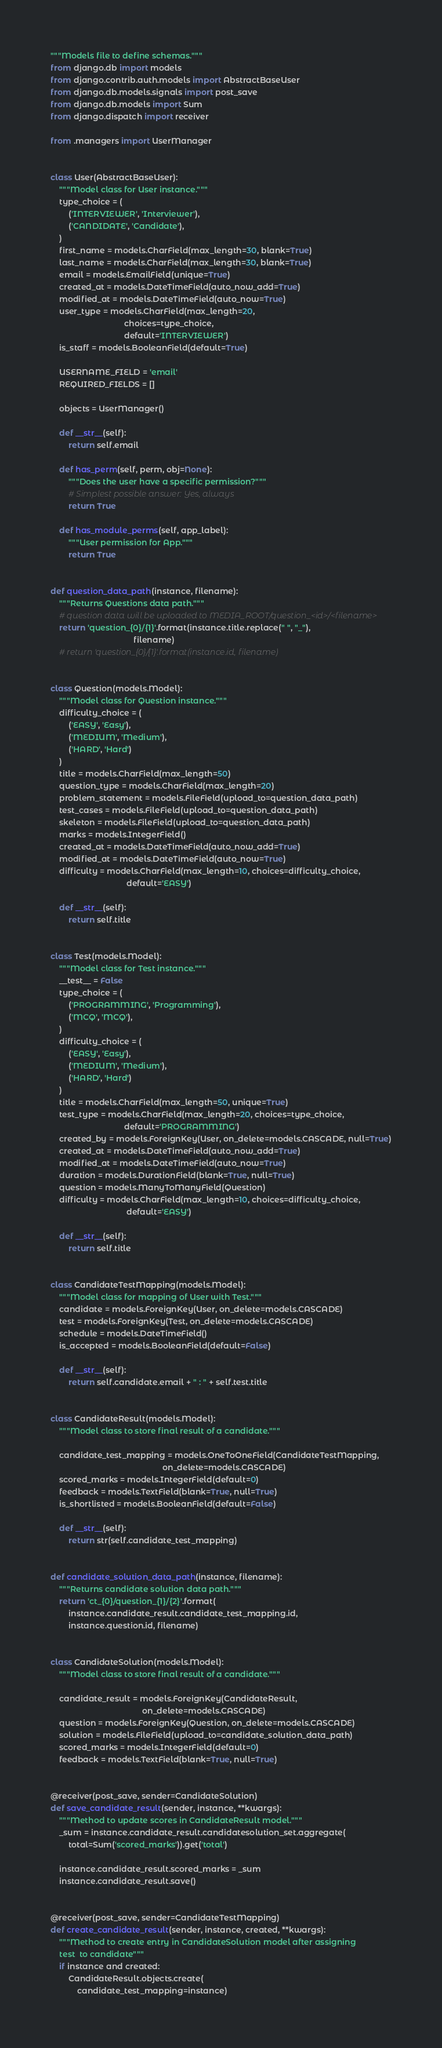Convert code to text. <code><loc_0><loc_0><loc_500><loc_500><_Python_>"""Models file to define schemas."""
from django.db import models
from django.contrib.auth.models import AbstractBaseUser
from django.db.models.signals import post_save
from django.db.models import Sum
from django.dispatch import receiver

from .managers import UserManager


class User(AbstractBaseUser):
    """Model class for User instance."""
    type_choice = (
        ('INTERVIEWER', 'Interviewer'),
        ('CANDIDATE', 'Candidate'),
    )
    first_name = models.CharField(max_length=30, blank=True)
    last_name = models.CharField(max_length=30, blank=True)
    email = models.EmailField(unique=True)
    created_at = models.DateTimeField(auto_now_add=True)
    modified_at = models.DateTimeField(auto_now=True)
    user_type = models.CharField(max_length=20,
                                 choices=type_choice,
                                 default='INTERVIEWER')
    is_staff = models.BooleanField(default=True)

    USERNAME_FIELD = 'email'
    REQUIRED_FIELDS = []

    objects = UserManager()

    def __str__(self):
        return self.email

    def has_perm(self, perm, obj=None):
        """Does the user have a specific permission?"""
        # Simplest possible answer: Yes, always
        return True

    def has_module_perms(self, app_label):
        """User permission for App."""
        return True


def question_data_path(instance, filename):
    """Returns Questions data path."""
    # question data will be uploaded to MEDIA_ROOT/question_<id>/<filename>
    return 'question_{0}/{1}'.format(instance.title.replace(" ", "_"),
                                     filename)
    # return 'question_{0}/{1}'.format(instance.id, filename)


class Question(models.Model):
    """Model class for Question instance."""
    difficulty_choice = (
        ('EASY', 'Easy'),
        ('MEDIUM', 'Medium'),
        ('HARD', 'Hard')
    )
    title = models.CharField(max_length=50)
    question_type = models.CharField(max_length=20)
    problem_statement = models.FileField(upload_to=question_data_path)
    test_cases = models.FileField(upload_to=question_data_path)
    skeleton = models.FileField(upload_to=question_data_path)
    marks = models.IntegerField()
    created_at = models.DateTimeField(auto_now_add=True)
    modified_at = models.DateTimeField(auto_now=True)
    difficulty = models.CharField(max_length=10, choices=difficulty_choice,
                                  default='EASY')

    def __str__(self):
        return self.title


class Test(models.Model):
    """Model class for Test instance."""
    __test__ = False
    type_choice = (
        ('PROGRAMMING', 'Programming'),
        ('MCQ', 'MCQ'),
    )
    difficulty_choice = (
        ('EASY', 'Easy'),
        ('MEDIUM', 'Medium'),
        ('HARD', 'Hard')
    )
    title = models.CharField(max_length=50, unique=True)
    test_type = models.CharField(max_length=20, choices=type_choice,
                                 default='PROGRAMMING')
    created_by = models.ForeignKey(User, on_delete=models.CASCADE, null=True)
    created_at = models.DateTimeField(auto_now_add=True)
    modified_at = models.DateTimeField(auto_now=True)
    duration = models.DurationField(blank=True, null=True)
    question = models.ManyToManyField(Question)
    difficulty = models.CharField(max_length=10, choices=difficulty_choice,
                                  default='EASY')

    def __str__(self):
        return self.title


class CandidateTestMapping(models.Model):
    """Model class for mapping of User with Test."""
    candidate = models.ForeignKey(User, on_delete=models.CASCADE)
    test = models.ForeignKey(Test, on_delete=models.CASCADE)
    schedule = models.DateTimeField()
    is_accepted = models.BooleanField(default=False)

    def __str__(self):
        return self.candidate.email + " : " + self.test.title


class CandidateResult(models.Model):
    """Model class to store final result of a candidate."""

    candidate_test_mapping = models.OneToOneField(CandidateTestMapping,
                                                  on_delete=models.CASCADE)
    scored_marks = models.IntegerField(default=0)
    feedback = models.TextField(blank=True, null=True)
    is_shortlisted = models.BooleanField(default=False)

    def __str__(self):
        return str(self.candidate_test_mapping)


def candidate_solution_data_path(instance, filename):
    """Returns candidate solution data path."""
    return 'ct_{0}/question_{1}/{2}'.format(
        instance.candidate_result.candidate_test_mapping.id,
        instance.question.id, filename)


class CandidateSolution(models.Model):
    """Model class to store final result of a candidate."""

    candidate_result = models.ForeignKey(CandidateResult,
                                         on_delete=models.CASCADE)
    question = models.ForeignKey(Question, on_delete=models.CASCADE)
    solution = models.FileField(upload_to=candidate_solution_data_path)
    scored_marks = models.IntegerField(default=0)
    feedback = models.TextField(blank=True, null=True)


@receiver(post_save, sender=CandidateSolution)
def save_candidate_result(sender, instance, **kwargs):
    """Method to update scores in CandidateResult model."""
    _sum = instance.candidate_result.candidatesolution_set.aggregate(
        total=Sum('scored_marks')).get('total')

    instance.candidate_result.scored_marks = _sum
    instance.candidate_result.save()


@receiver(post_save, sender=CandidateTestMapping)
def create_candidate_result(sender, instance, created, **kwargs):
    """Method to create entry in CandidateSolution model after assigning
    test  to candidate"""
    if instance and created:
        CandidateResult.objects.create(
            candidate_test_mapping=instance)
</code> 